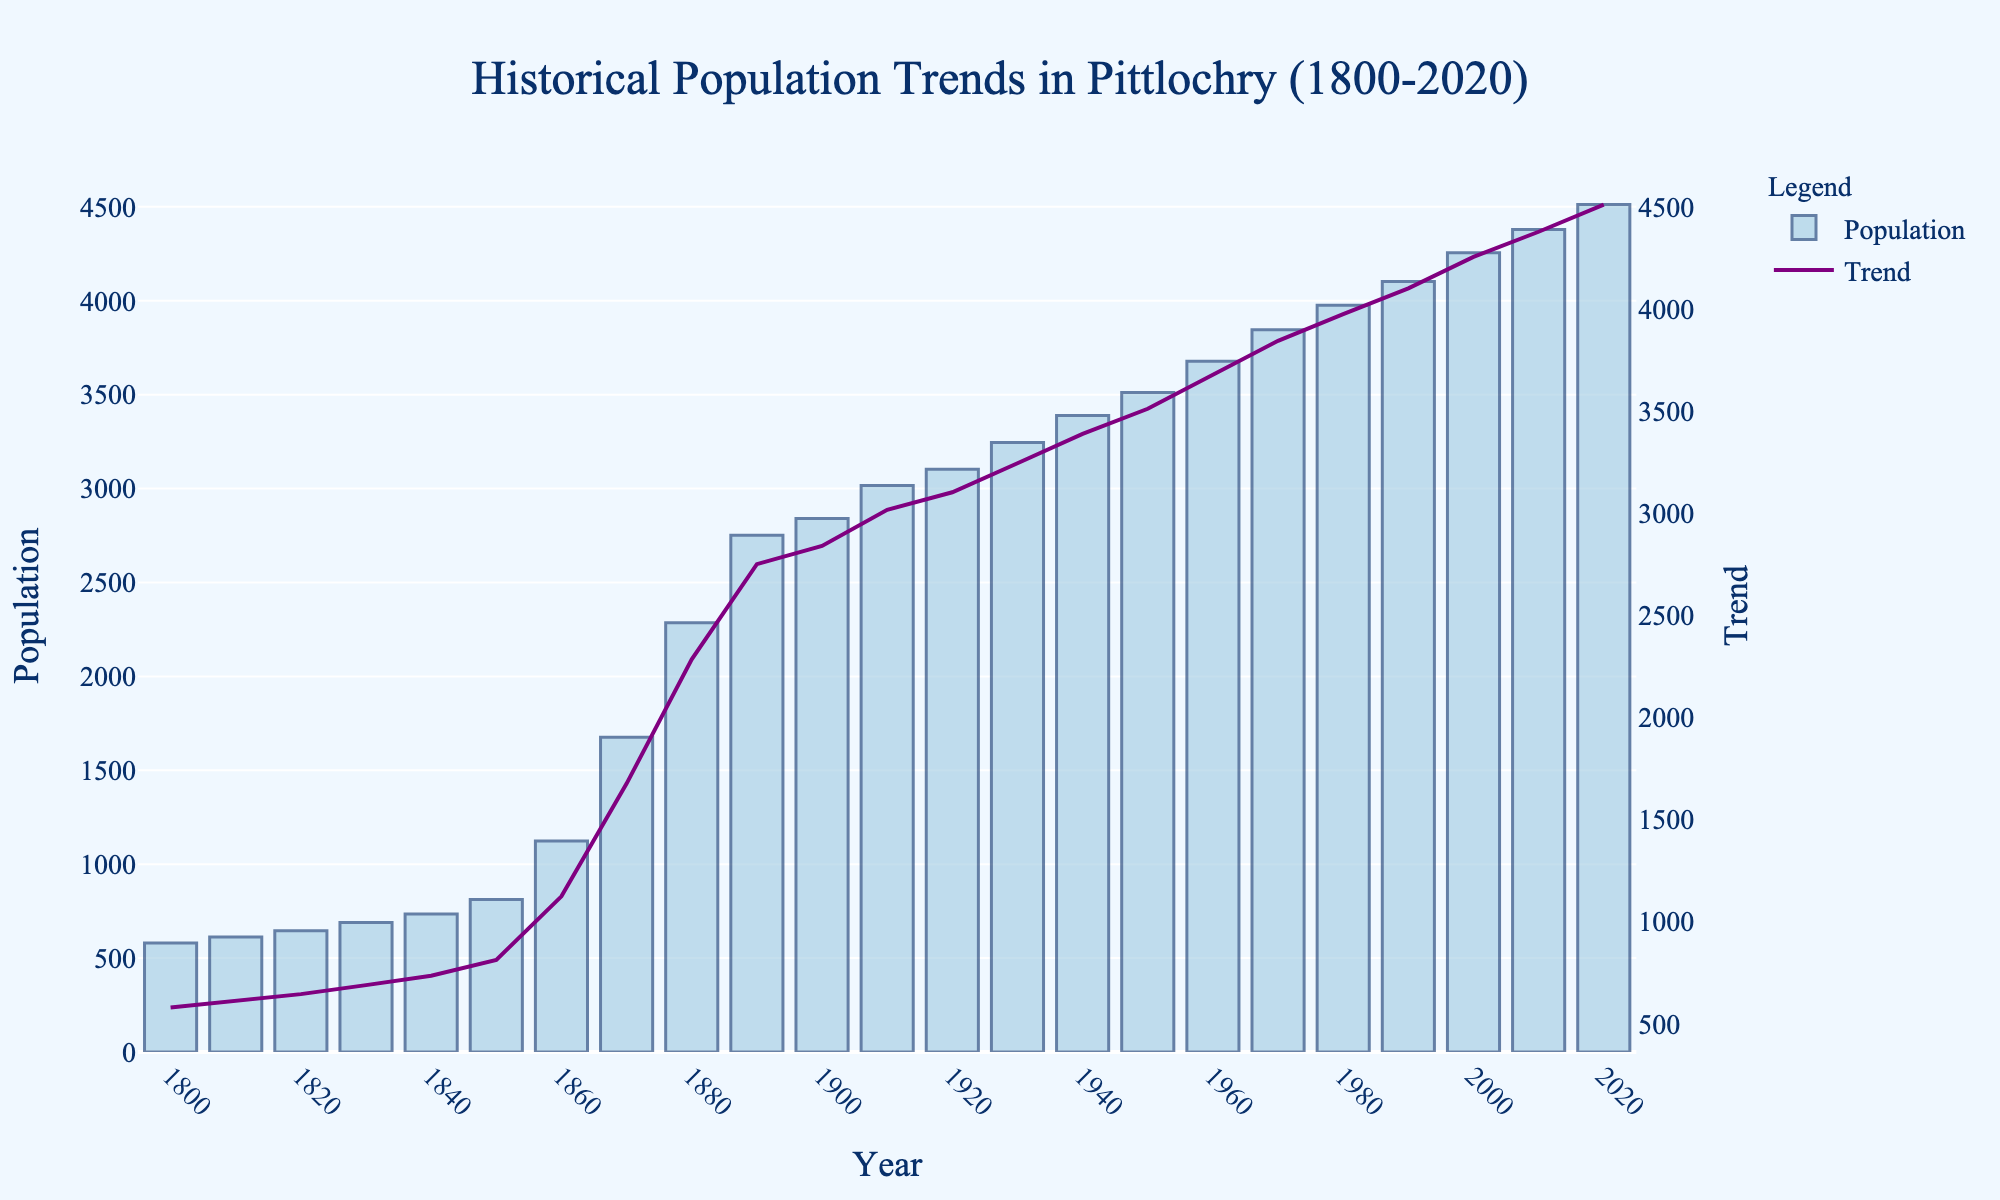When did Pittlochry's population double from its 1850 figure? The population in 1850 was 812. Looking at the bar heights, the population doubled when it reached approximately 1624. By 1870, the population was 1676, more than twice the 1850 figure.
Answer: 1870 During which decade did Pittlochry's population see the highest increase? To find the highest increase, calculate the difference between each decade. The biggest jump is from 1880 (2285) to 1890 (2751), an increase of 466.
Answer: 1880-1890 What was the population trend during World War I (1914-1918)? During WWI (1914-1918), the population would be between the markers for 1910 (3017) and 1920 (3103). The population trend line shows a slight increase.
Answer: Slight increase Compare the population growth between the decades 1800-1850 and 1950-2000. From 1800 (580) to 1850 (812), the increase is 232. From 1950 (3512) to 2000 (4256), the increase is 744.
Answer: The growth from 1950 to 2000 was greater Which year marks the first time Pittlochry's population exceeded 3000? Look at the bars to find when the population surpasses 3000. The bar for 1910 shows a population of 3017.
Answer: 1910 How much did the population increase from 1900 to 2000? Subtract the 1900 population (2840) from the 2000 population (4256): 4256 - 2840 = 1416.
Answer: 1416 During which decade did Pittlochry see its least population growth? Compare the height differences of each decade's bars. The smallest growth is from 1930 (3245) to 1940 (3389), an increase of 144.
Answer: 1930-1940 What was the average population growth per decade from 1800 to 2020? First, calculate total growth: 4512 (2020) - 580 (1800) = 3932. There are 22 decades, so divide: 3932 / 22 ≈ 178.
Answer: Approximately 178 How does the population comparison between 1820 and 2020 illustrate long-term growth? The population in 1820 was 645, and in 2020 it was 4512. This shows significant long-term growth as 4512 is much larger than 645.
Answer: Significant long-term growth Identify the decade where Pittlochry's population first exceeded 4000. The bars show the population exceeding 4000 first in 1990 (4102).
Answer: 1990 